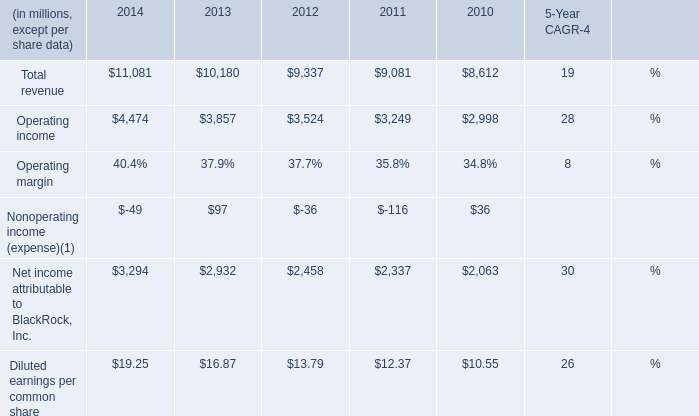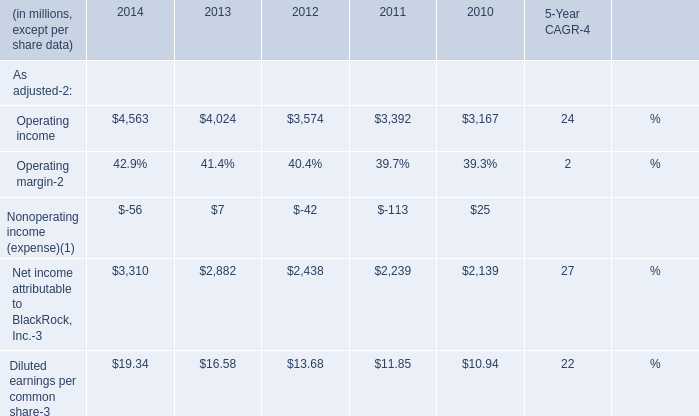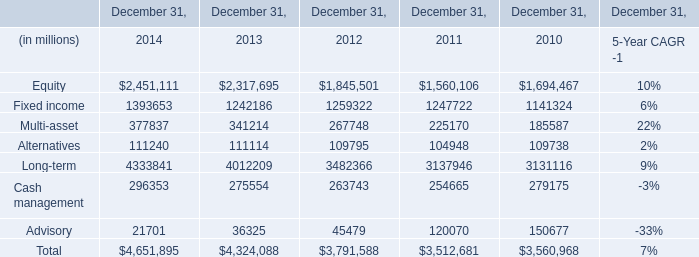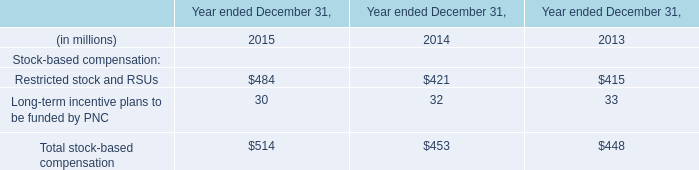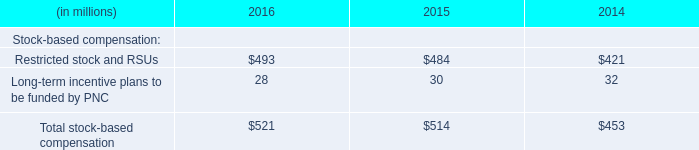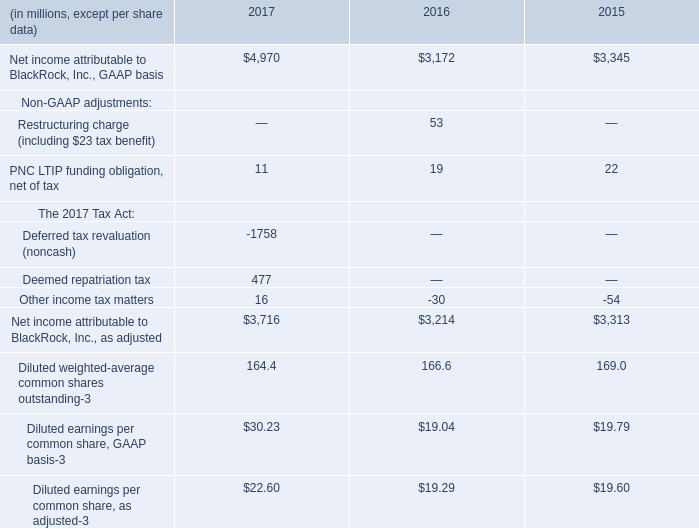What's the average of Total revenue and Operating income in 2014? (in million) 
Computations: ((11081 + 4474) / 2)
Answer: 7777.5. 